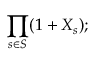<formula> <loc_0><loc_0><loc_500><loc_500>\prod _ { s \in S } ( 1 + X _ { s } ) ;</formula> 